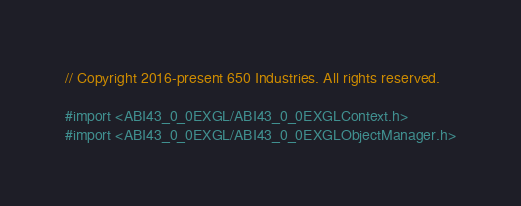Convert code to text. <code><loc_0><loc_0><loc_500><loc_500><_ObjectiveC_>// Copyright 2016-present 650 Industries. All rights reserved.

#import <ABI43_0_0EXGL/ABI43_0_0EXGLContext.h>
#import <ABI43_0_0EXGL/ABI43_0_0EXGLObjectManager.h>
</code> 